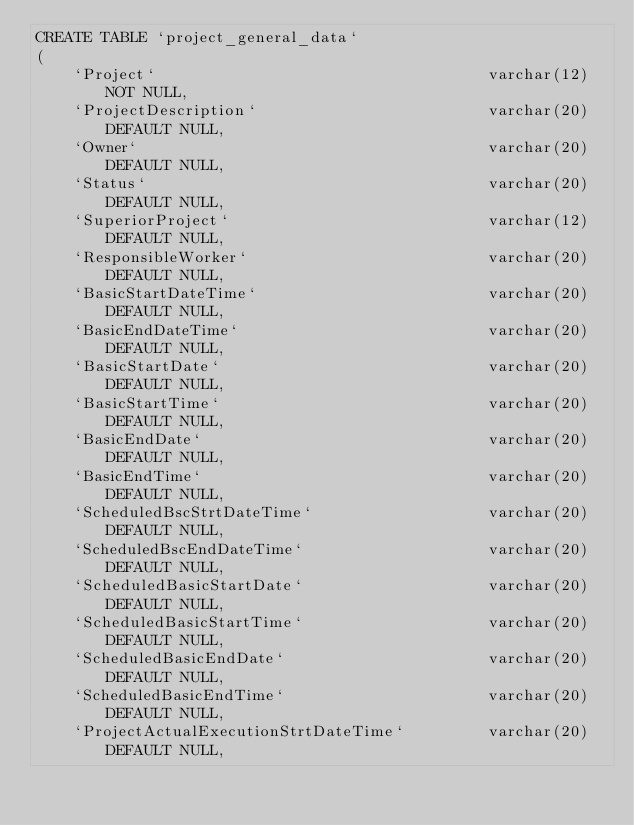Convert code to text. <code><loc_0><loc_0><loc_500><loc_500><_SQL_>CREATE TABLE `project_general_data`
(
    `Project`                                    varchar(12) NOT NULL,
    `ProjectDescription`                         varchar(20) DEFAULT NULL,
    `Owner`                                      varchar(20) DEFAULT NULL,
    `Status`                                     varchar(20) DEFAULT NULL,
    `SuperiorProject`                            varchar(12) DEFAULT NULL,
    `ResponsibleWorker`                          varchar(20) DEFAULT NULL,
    `BasicStartDateTime`                         varchar(20) DEFAULT NULL,
    `BasicEndDateTime`                           varchar(20) DEFAULT NULL,
    `BasicStartDate`                             varchar(20) DEFAULT NULL,
    `BasicStartTime`                             varchar(20) DEFAULT NULL,
    `BasicEndDate`                               varchar(20) DEFAULT NULL,
    `BasicEndTime`                               varchar(20) DEFAULT NULL,
    `ScheduledBscStrtDateTime`                   varchar(20) DEFAULT NULL,
    `ScheduledBscEndDateTime`                    varchar(20) DEFAULT NULL,
    `ScheduledBasicStartDate`                    varchar(20) DEFAULT NULL,
    `ScheduledBasicStartTime`                    varchar(20) DEFAULT NULL,
    `ScheduledBasicEndDate`                      varchar(20) DEFAULT NULL,
    `ScheduledBasicEndTime`                      varchar(20) DEFAULT NULL,
    `ProjectActualExecutionStrtDateTime`         varchar(20) DEFAULT NULL,</code> 